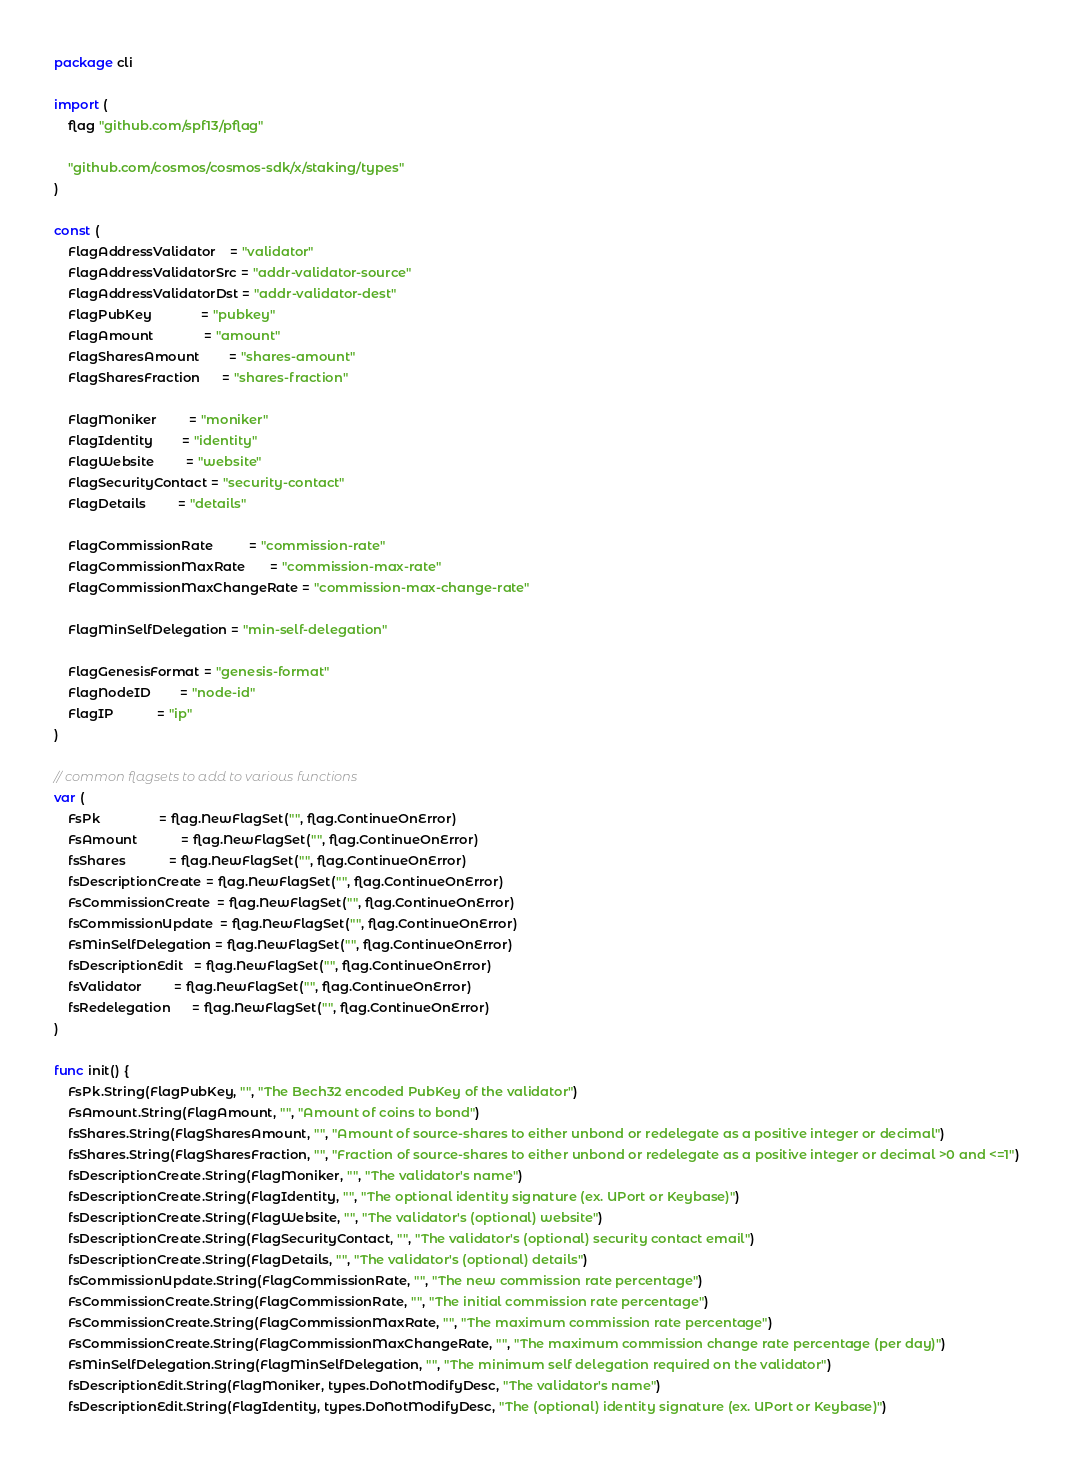Convert code to text. <code><loc_0><loc_0><loc_500><loc_500><_Go_>package cli

import (
	flag "github.com/spf13/pflag"

	"github.com/cosmos/cosmos-sdk/x/staking/types"
)

const (
	FlagAddressValidator    = "validator"
	FlagAddressValidatorSrc = "addr-validator-source"
	FlagAddressValidatorDst = "addr-validator-dest"
	FlagPubKey              = "pubkey"
	FlagAmount              = "amount"
	FlagSharesAmount        = "shares-amount"
	FlagSharesFraction      = "shares-fraction"

	FlagMoniker         = "moniker"
	FlagIdentity        = "identity"
	FlagWebsite         = "website"
	FlagSecurityContact = "security-contact"
	FlagDetails         = "details"

	FlagCommissionRate          = "commission-rate"
	FlagCommissionMaxRate       = "commission-max-rate"
	FlagCommissionMaxChangeRate = "commission-max-change-rate"

	FlagMinSelfDelegation = "min-self-delegation"

	FlagGenesisFormat = "genesis-format"
	FlagNodeID        = "node-id"
	FlagIP            = "ip"
)

// common flagsets to add to various functions
var (
	FsPk                = flag.NewFlagSet("", flag.ContinueOnError)
	FsAmount            = flag.NewFlagSet("", flag.ContinueOnError)
	fsShares            = flag.NewFlagSet("", flag.ContinueOnError)
	fsDescriptionCreate = flag.NewFlagSet("", flag.ContinueOnError)
	FsCommissionCreate  = flag.NewFlagSet("", flag.ContinueOnError)
	fsCommissionUpdate  = flag.NewFlagSet("", flag.ContinueOnError)
	FsMinSelfDelegation = flag.NewFlagSet("", flag.ContinueOnError)
	fsDescriptionEdit   = flag.NewFlagSet("", flag.ContinueOnError)
	fsValidator         = flag.NewFlagSet("", flag.ContinueOnError)
	fsRedelegation      = flag.NewFlagSet("", flag.ContinueOnError)
)

func init() {
	FsPk.String(FlagPubKey, "", "The Bech32 encoded PubKey of the validator")
	FsAmount.String(FlagAmount, "", "Amount of coins to bond")
	fsShares.String(FlagSharesAmount, "", "Amount of source-shares to either unbond or redelegate as a positive integer or decimal")
	fsShares.String(FlagSharesFraction, "", "Fraction of source-shares to either unbond or redelegate as a positive integer or decimal >0 and <=1")
	fsDescriptionCreate.String(FlagMoniker, "", "The validator's name")
	fsDescriptionCreate.String(FlagIdentity, "", "The optional identity signature (ex. UPort or Keybase)")
	fsDescriptionCreate.String(FlagWebsite, "", "The validator's (optional) website")
	fsDescriptionCreate.String(FlagSecurityContact, "", "The validator's (optional) security contact email")
	fsDescriptionCreate.String(FlagDetails, "", "The validator's (optional) details")
	fsCommissionUpdate.String(FlagCommissionRate, "", "The new commission rate percentage")
	FsCommissionCreate.String(FlagCommissionRate, "", "The initial commission rate percentage")
	FsCommissionCreate.String(FlagCommissionMaxRate, "", "The maximum commission rate percentage")
	FsCommissionCreate.String(FlagCommissionMaxChangeRate, "", "The maximum commission change rate percentage (per day)")
	FsMinSelfDelegation.String(FlagMinSelfDelegation, "", "The minimum self delegation required on the validator")
	fsDescriptionEdit.String(FlagMoniker, types.DoNotModifyDesc, "The validator's name")
	fsDescriptionEdit.String(FlagIdentity, types.DoNotModifyDesc, "The (optional) identity signature (ex. UPort or Keybase)")</code> 